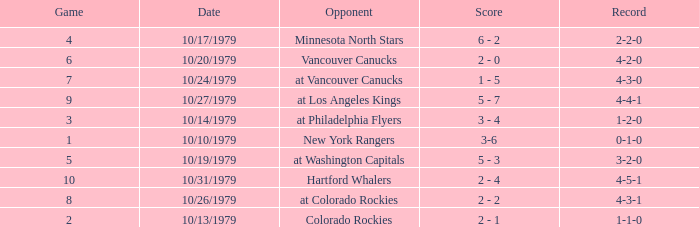What date is the record 4-3-0? 10/24/1979. Help me parse the entirety of this table. {'header': ['Game', 'Date', 'Opponent', 'Score', 'Record'], 'rows': [['4', '10/17/1979', 'Minnesota North Stars', '6 - 2', '2-2-0'], ['6', '10/20/1979', 'Vancouver Canucks', '2 - 0', '4-2-0'], ['7', '10/24/1979', 'at Vancouver Canucks', '1 - 5', '4-3-0'], ['9', '10/27/1979', 'at Los Angeles Kings', '5 - 7', '4-4-1'], ['3', '10/14/1979', 'at Philadelphia Flyers', '3 - 4', '1-2-0'], ['1', '10/10/1979', 'New York Rangers', '3-6', '0-1-0'], ['5', '10/19/1979', 'at Washington Capitals', '5 - 3', '3-2-0'], ['10', '10/31/1979', 'Hartford Whalers', '2 - 4', '4-5-1'], ['8', '10/26/1979', 'at Colorado Rockies', '2 - 2', '4-3-1'], ['2', '10/13/1979', 'Colorado Rockies', '2 - 1', '1-1-0']]} 